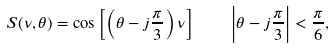<formula> <loc_0><loc_0><loc_500><loc_500>S ( \nu , \theta ) = \cos \left [ \left ( \theta - j \frac { \pi } { 3 } \right ) \nu \right ] \quad \left | \theta - j \frac { \pi } { 3 } \right | < \frac { \pi } { 6 } , \,</formula> 